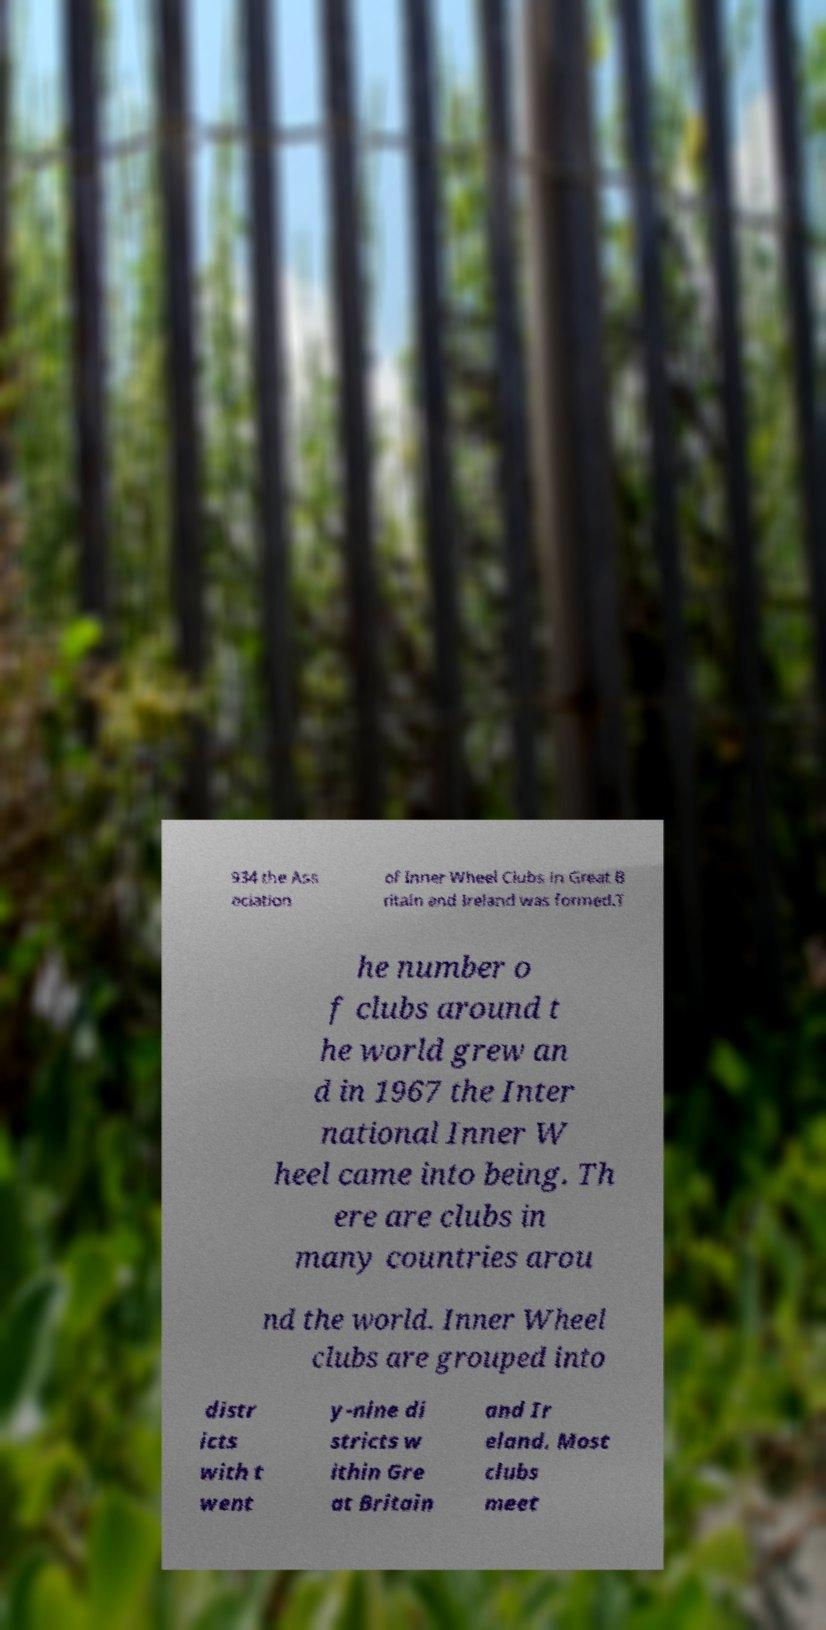There's text embedded in this image that I need extracted. Can you transcribe it verbatim? 934 the Ass ociation of Inner Wheel Clubs in Great B ritain and Ireland was formed.T he number o f clubs around t he world grew an d in 1967 the Inter national Inner W heel came into being. Th ere are clubs in many countries arou nd the world. Inner Wheel clubs are grouped into distr icts with t went y-nine di stricts w ithin Gre at Britain and Ir eland. Most clubs meet 